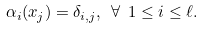<formula> <loc_0><loc_0><loc_500><loc_500>\alpha _ { i } ( x _ { j } ) = \delta _ { i , j } , \text { } \forall \text { } 1 \leq i \leq \ell .</formula> 